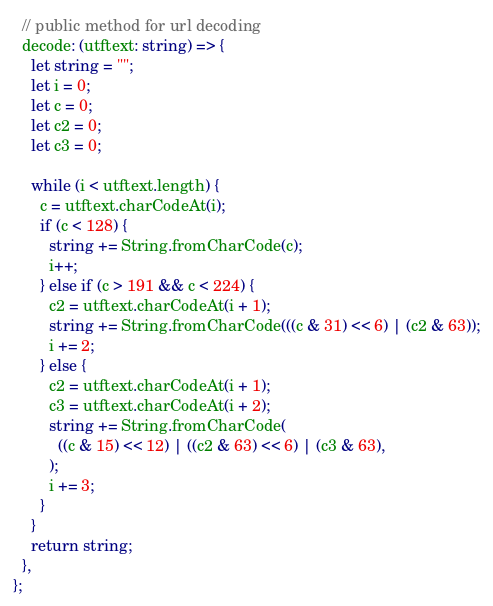<code> <loc_0><loc_0><loc_500><loc_500><_TypeScript_>  // public method for url decoding
  decode: (utftext: string) => {
    let string = "";
    let i = 0;
    let c = 0;
    let c2 = 0;
    let c3 = 0;

    while (i < utftext.length) {
      c = utftext.charCodeAt(i);
      if (c < 128) {
        string += String.fromCharCode(c);
        i++;
      } else if (c > 191 && c < 224) {
        c2 = utftext.charCodeAt(i + 1);
        string += String.fromCharCode(((c & 31) << 6) | (c2 & 63));
        i += 2;
      } else {
        c2 = utftext.charCodeAt(i + 1);
        c3 = utftext.charCodeAt(i + 2);
        string += String.fromCharCode(
          ((c & 15) << 12) | ((c2 & 63) << 6) | (c3 & 63),
        );
        i += 3;
      }
    }
    return string;
  },
};
</code> 